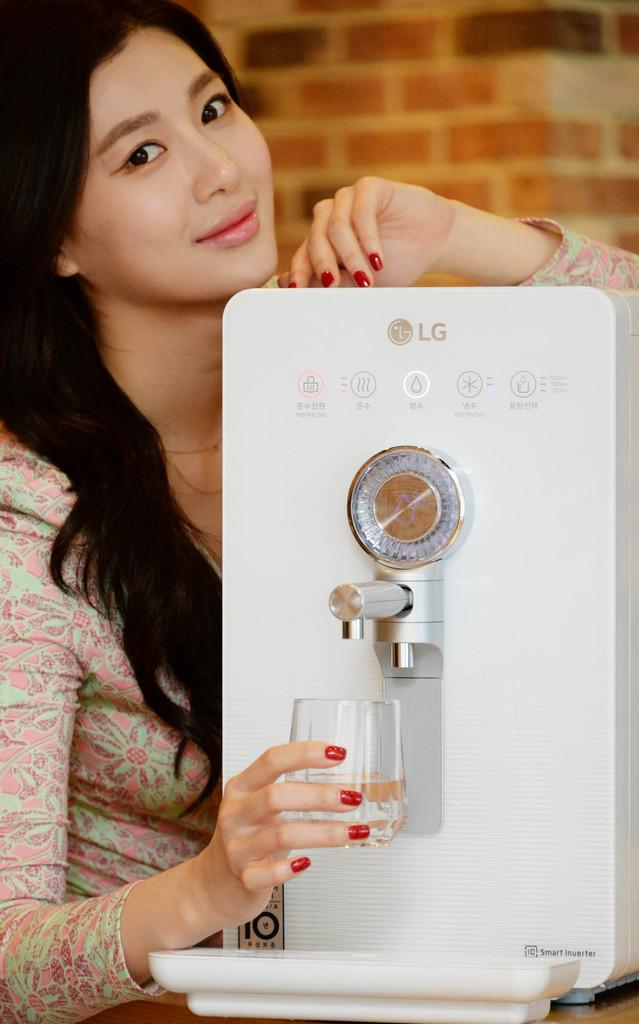<image>
Summarize the visual content of the image. A woman fills a glass from an LG machine that is all white. 